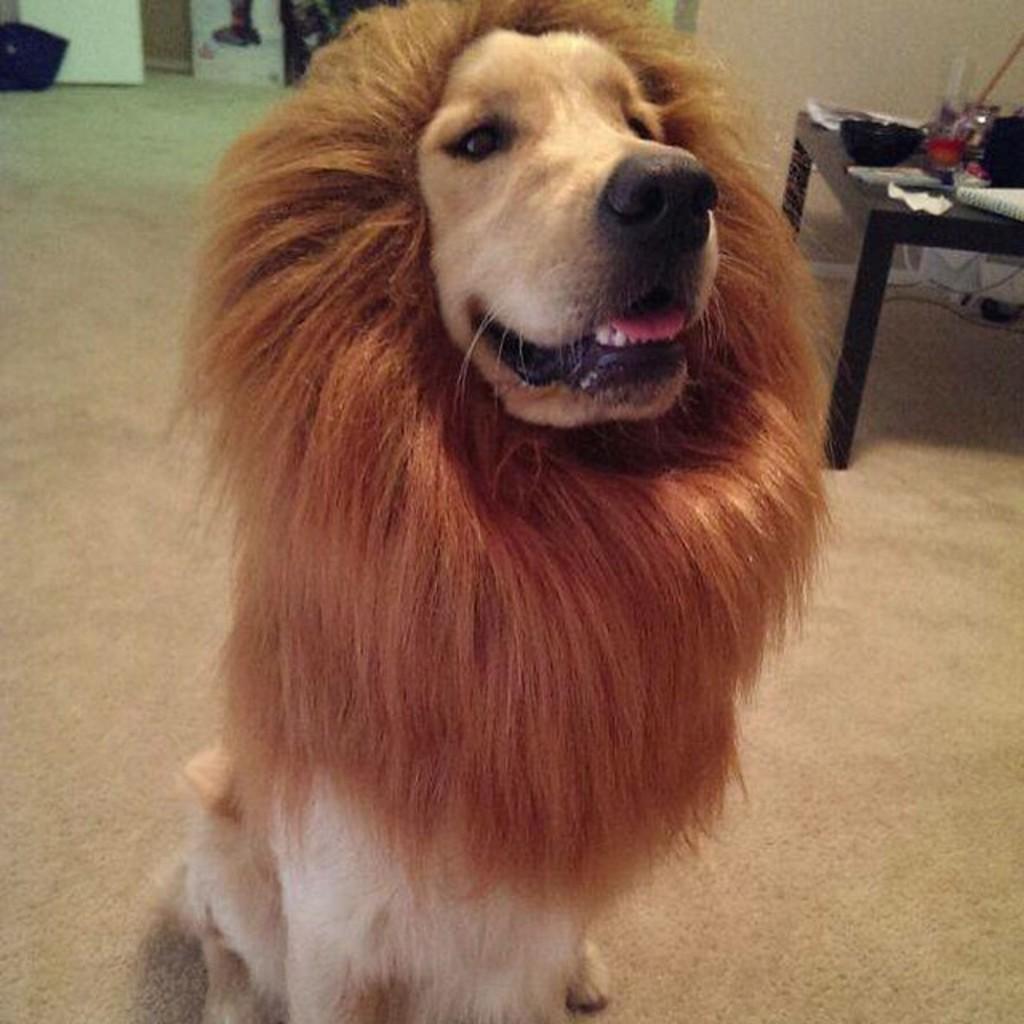In one or two sentences, can you explain what this image depicts? In this image we can see a dog wearing a lion's mask is standing on the floor. In the background we can see a table on which few things are placed. 